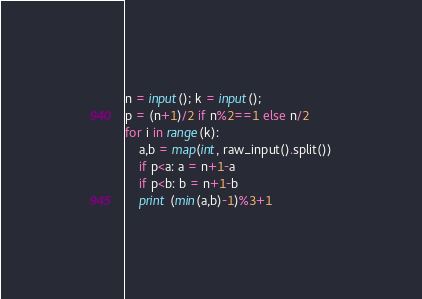Convert code to text. <code><loc_0><loc_0><loc_500><loc_500><_Python_>n = input(); k = input();
p = (n+1)/2 if n%2==1 else n/2
for i in range(k):
    a,b = map(int, raw_input().split())
    if p<a: a = n+1-a
    if p<b: b = n+1-b
    print (min(a,b)-1)%3+1</code> 